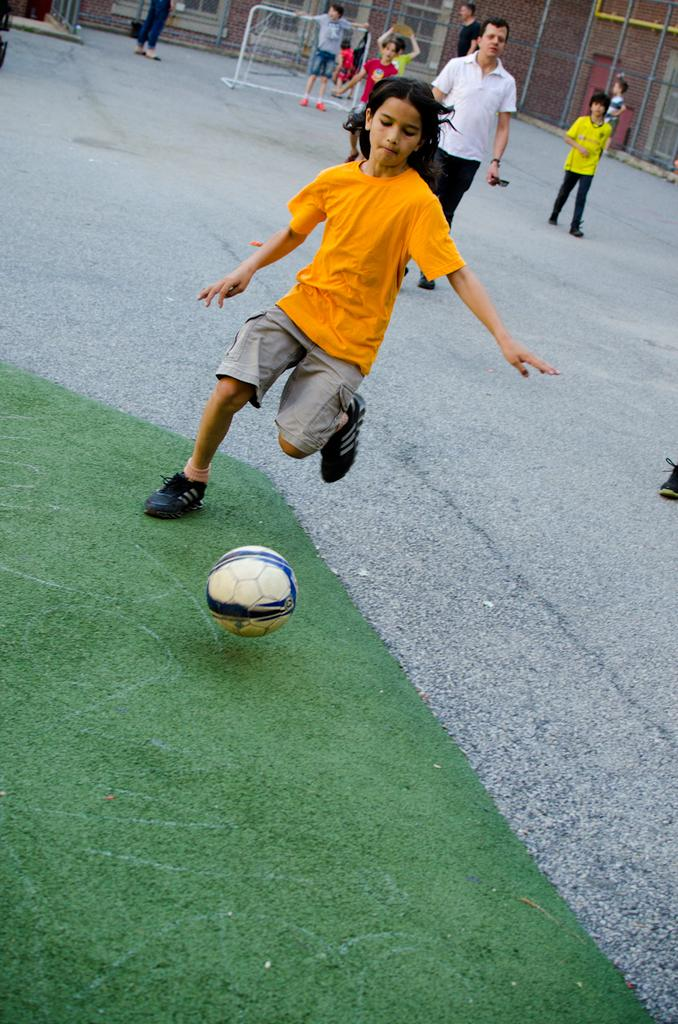Who is the main subject in the image? There is a boy in the image. What is the boy doing in the image? The boy is playing football. Can you describe the environment in the image? There is green grass in the image, and there are people standing in the background. What type of tail can be seen on the football in the image? There is no tail present on the football in the image. How does the acoustics of the environment affect the sound of the football being kicked? The provided facts do not mention any information about the acoustics of the environment, so it cannot be determined how it affects the sound of the football being kicked. 